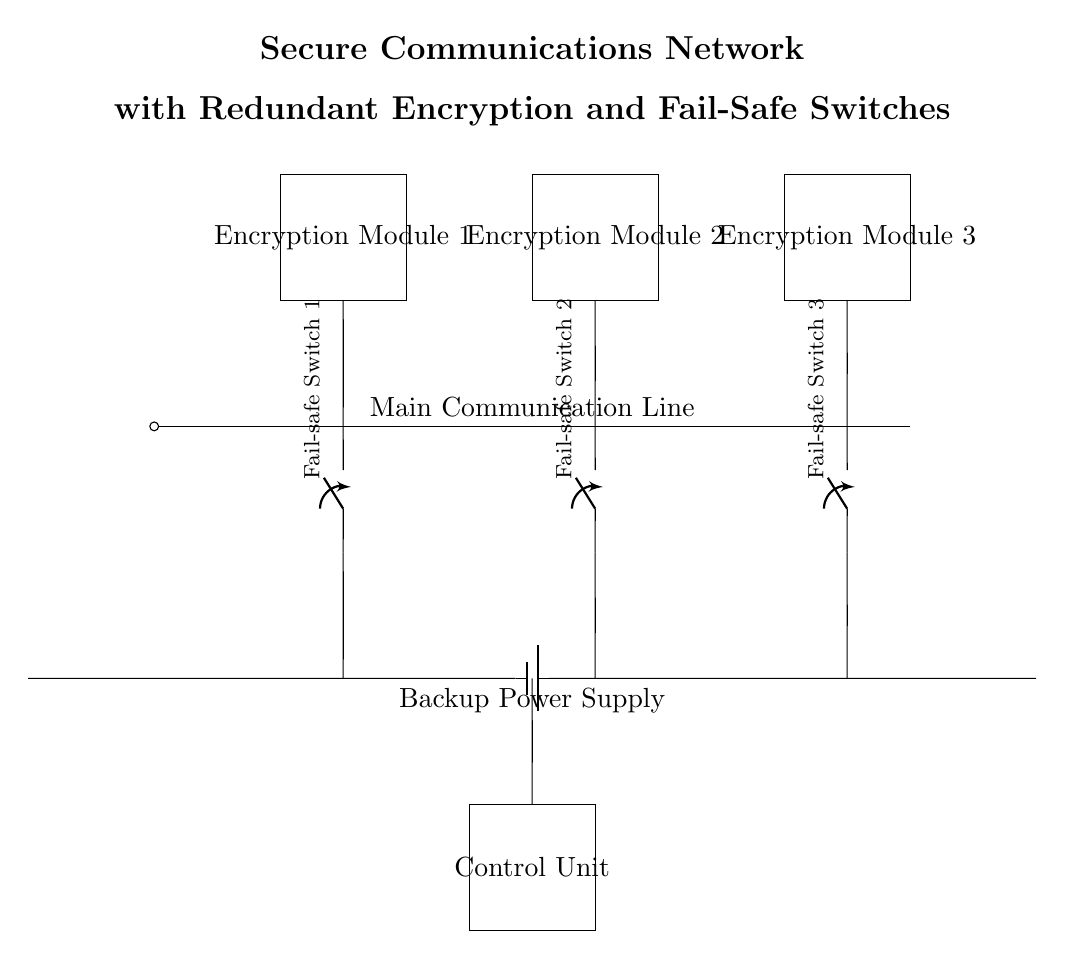What is the function of each encryption module? Each encryption module is designed to encode the data being transmitted over the main communication line, ensuring secure communication. The three modules provide redundant encryption to enhance security.
Answer: Encode data How many fail-safe switches are there? There are three fail-safe switches in the circuit diagram, one associated with each encryption module. They allow for safe disconnection in case of a malfunction.
Answer: Three What component provides backup power? The backup power supply is indicated by the battery symbol in the circuit diagram, ensuring that the communication remains operational during power failure.
Answer: Battery What role does the control unit play? The control unit manages the operations of the encryption modules and fail-safe switches, coordinating the secure communication process to maintain efficiency.
Answer: Manage operations Which module is connected to the first fail-safe switch? The first fail-safe switch is connected to Encryption Module 1, located at the leftmost position in the diagram, ensuring redundancy in the secure networking process.
Answer: Encryption Module 1 If one encryption module fails, how is redundancy ensured? Redundancy is ensured by using two additional encryption modules in parallel, which can take over the encryption process if one module fails, maintaining the integrity of the secure communication.
Answer: Two additional modules 